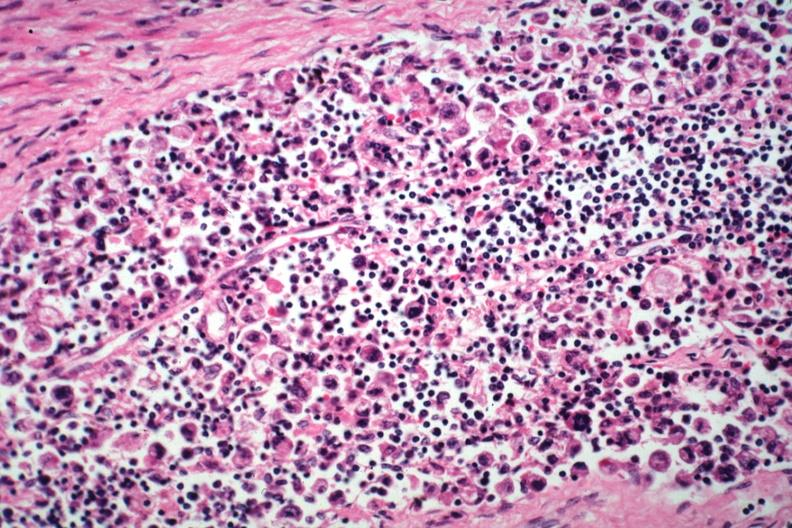what is present?
Answer the question using a single word or phrase. Metastatic carcinoma 